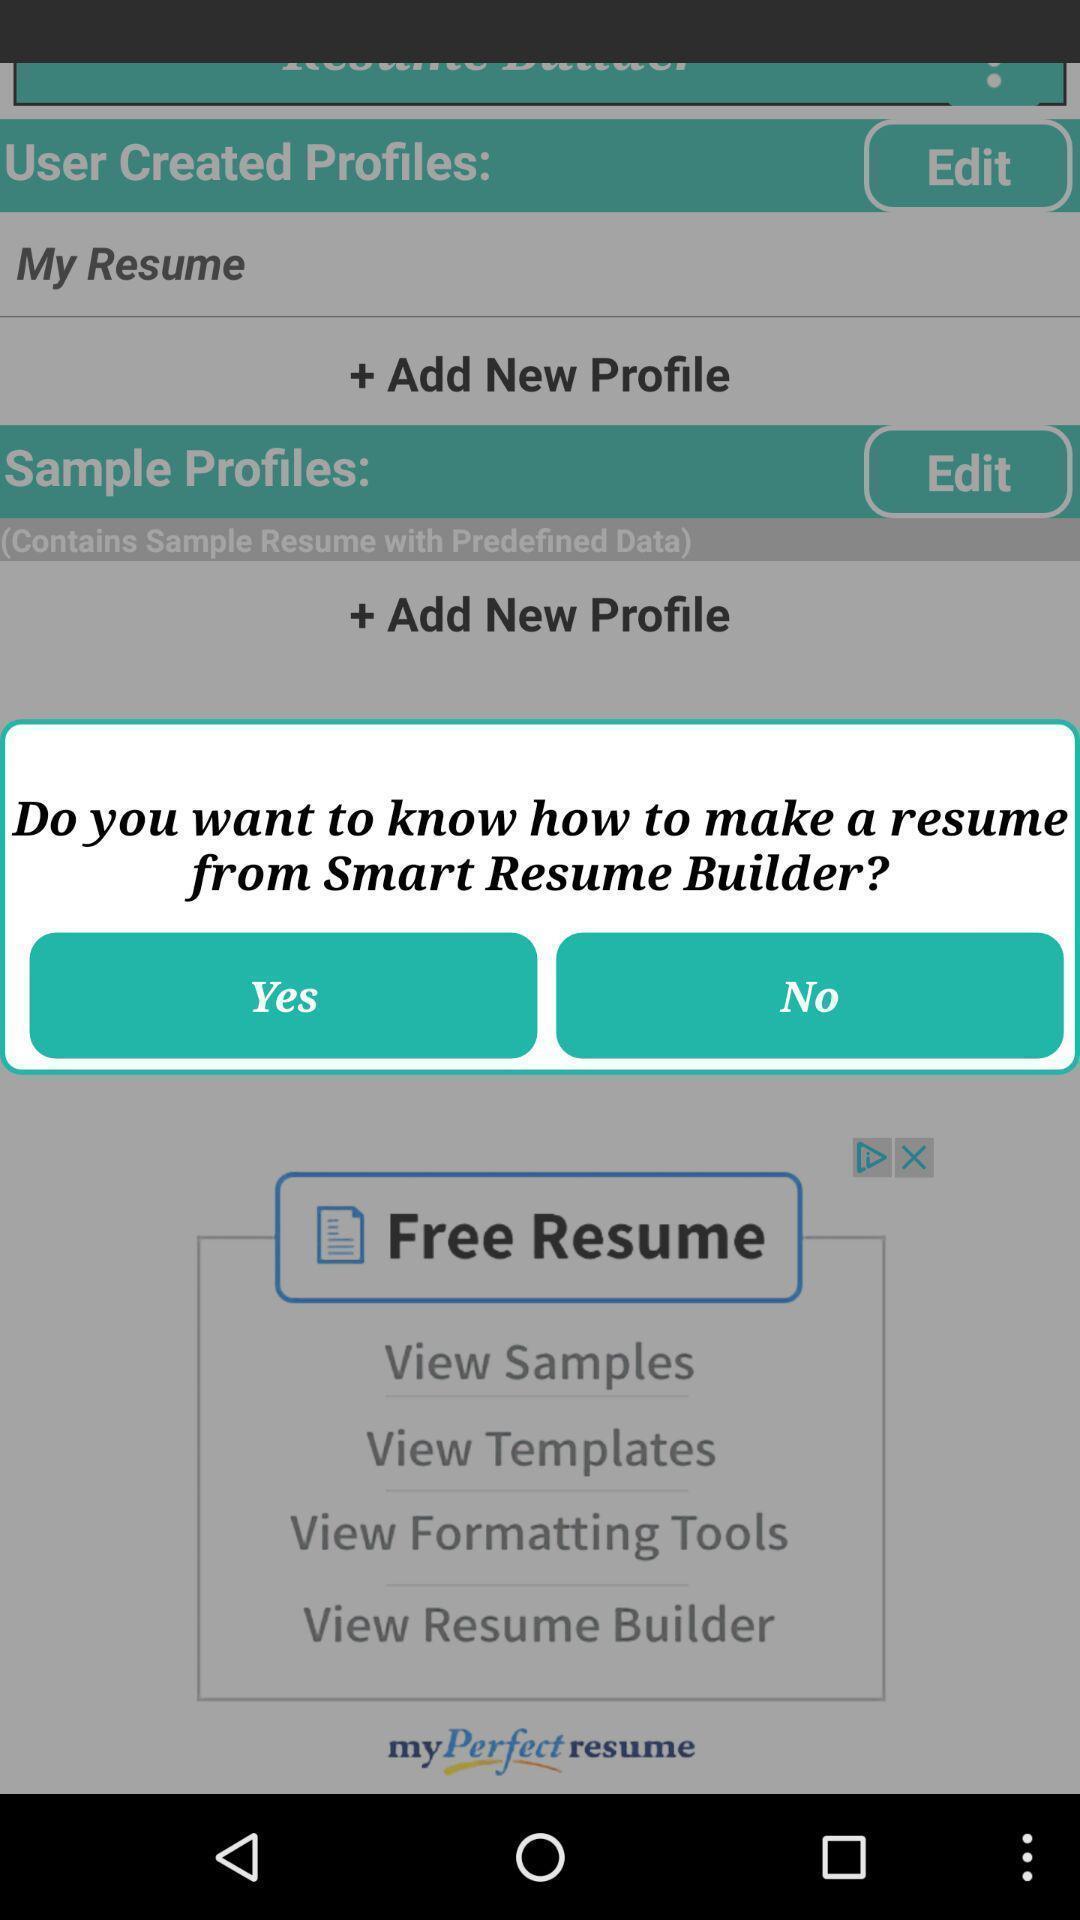Please provide a description for this image. Pop-up with options in a resume building app. 